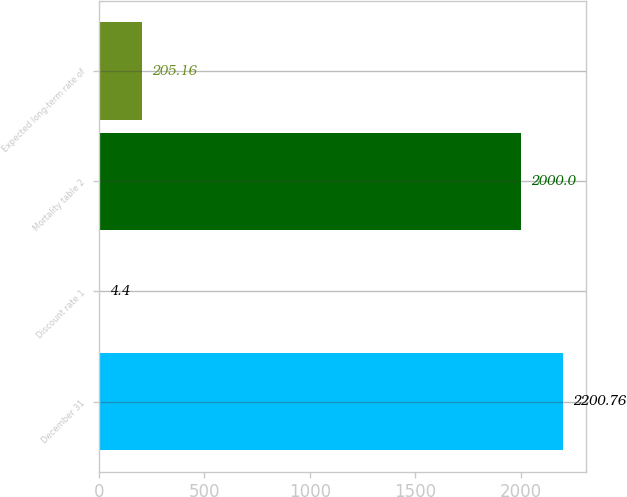Convert chart. <chart><loc_0><loc_0><loc_500><loc_500><bar_chart><fcel>December 31<fcel>Discount rate 1<fcel>Mortality table 2<fcel>Expected long-term rate of<nl><fcel>2200.76<fcel>4.4<fcel>2000<fcel>205.16<nl></chart> 